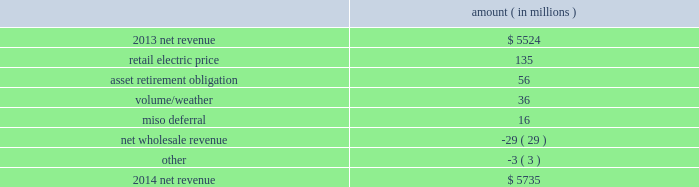Entergy corporation and subsidiaries management 2019s financial discussion and analysis net revenue utility following is an analysis of the change in net revenue comparing 2014 to 2013 .
Amount ( in millions ) .
The retail electric price variance is primarily due to : 2022 increases in the energy efficiency rider at entergy arkansas , as approved by the apsc , effective july 2013 and july 2014 .
Energy efficiency revenues are offset by costs included in other operation and maintenance expenses and have minimal effect on net income ; 2022 the effect of the apsc 2019s order in entergy arkansas 2019s 2013 rate case , including an annual base rate increase effective january 2014 offset by a miso rider to provide customers credits in rates for transmission revenue received through miso ; 2022 a formula rate plan increase at entergy mississippi , as approved by the mspc , effective september 2013 ; 2022 an increase in entergy mississippi 2019s storm damage rider , as approved by the mpsc , effective october 2013 .
The increase in the storm damage rider is offset by other operation and maintenance expenses and has no effect on net income ; 2022 an annual base rate increase at entergy texas , effective april 2014 , as a result of the puct 2019s order in the september 2013 rate case ; and 2022 a formula rate plan increase at entergy louisiana , as approved by the lpsc , effective december 2014 .
See note 2 to the financial statements for a discussion of rate proceedings .
The asset retirement obligation affects net revenue because entergy records a regulatory debit or credit for the difference between asset retirement obligation-related expenses and trust earnings plus asset retirement obligation- related costs collected in revenue .
The variance is primarily caused by increases in regulatory credits because of decreases in decommissioning trust earnings and increases in depreciation and accretion expenses and increases in regulatory credits to realign the asset retirement obligation regulatory assets with regulatory treatment .
The volume/weather variance is primarily due to an increase of 3129 gwh , or 3% ( 3 % ) , in billed electricity usage primarily due to an increase in sales to industrial customers and the effect of more favorable weather on residential sales .
The increase in industrial sales was primarily due to expansions , recovery of a major refining customer from an unplanned outage in 2013 , and continued moderate growth in the manufacturing sector .
The miso deferral variance is primarily due to the deferral in 2014 of the non-fuel miso-related charges , as approved by the lpsc and the mpsc , partially offset by the deferral in april 2013 , as approved by the apsc , of costs incurred from march 2010 through december 2012 related to the transition and implementation of joining the miso .
What was the percent of the change in the net revenue from 2013 to 2014? 
Computations: ((5735 - 5524) / 5524)
Answer: 0.0382. 